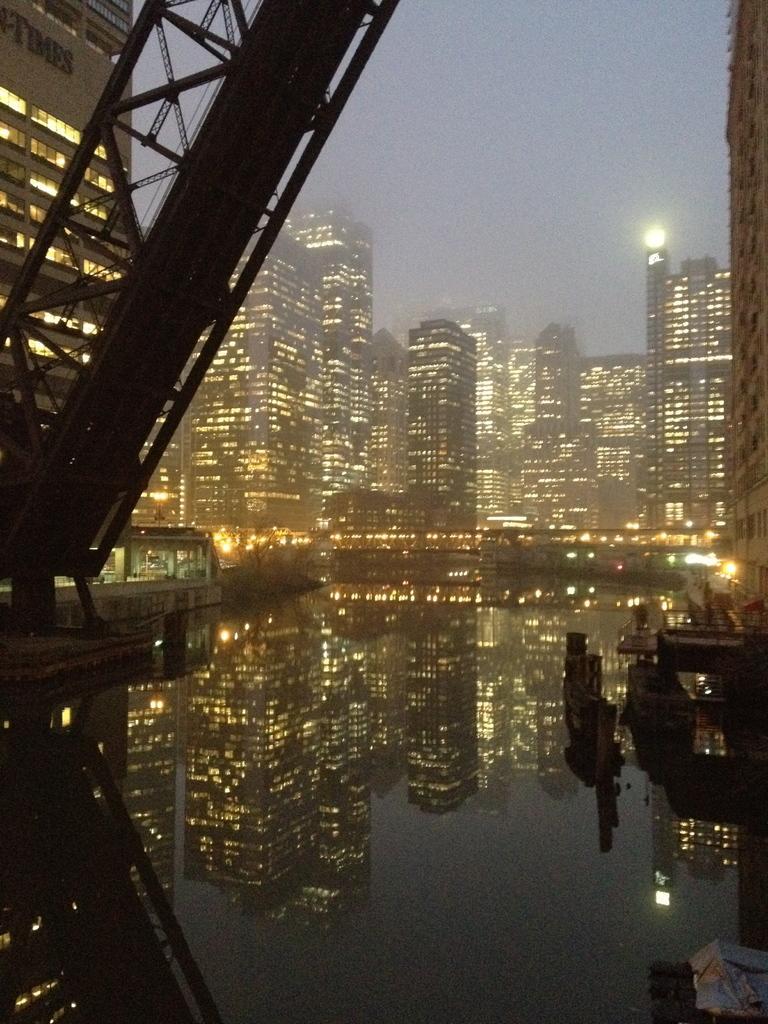Describe this image in one or two sentences. In this picture we can see the water, buildings, lights and some objects and in the background we can see the sky. 